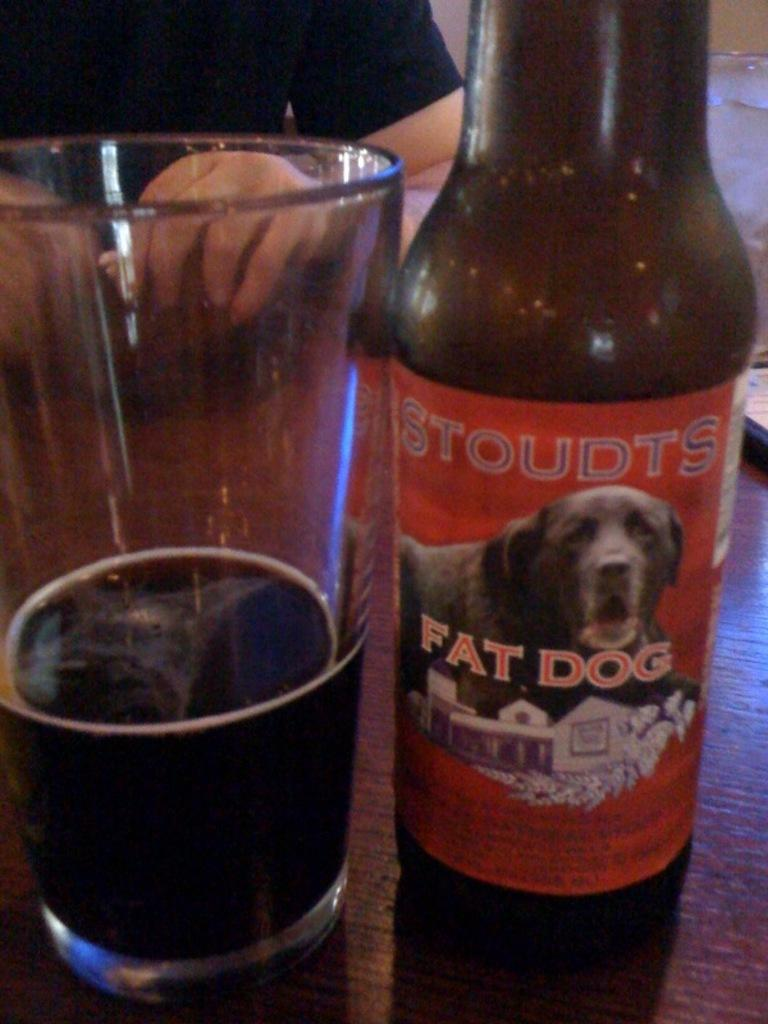<image>
Summarize the visual content of the image. A bottle of fat dog ale is on a brown table next to a glass with ale in it. 